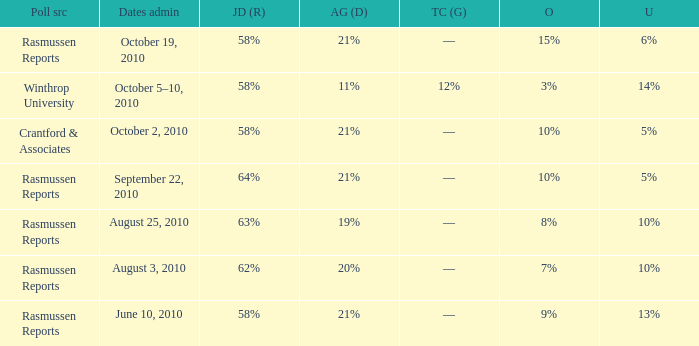What was the vote for Alvin Green when other was 9%? 21%. 